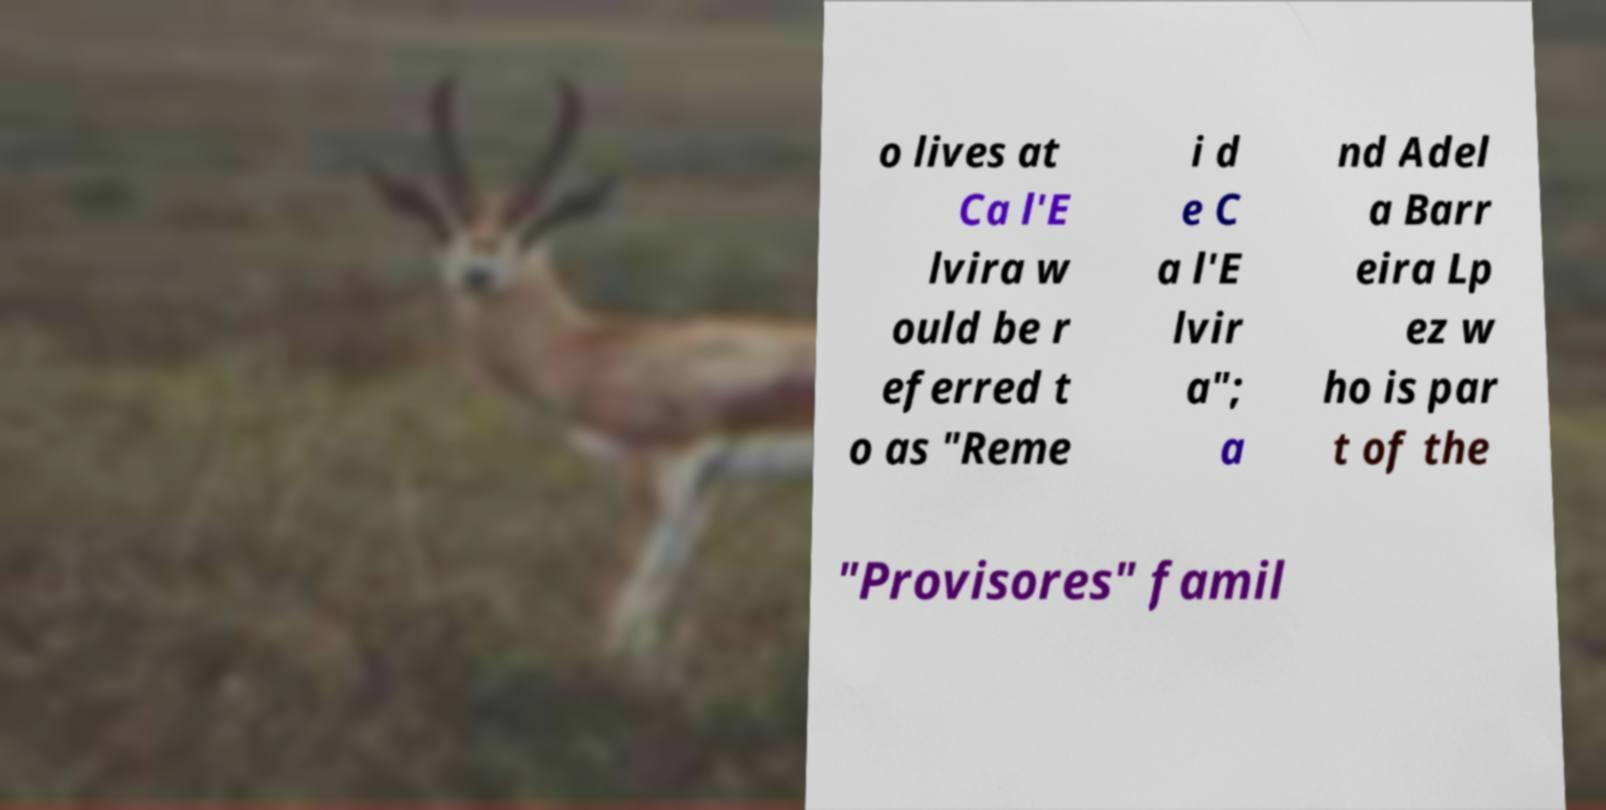There's text embedded in this image that I need extracted. Can you transcribe it verbatim? o lives at Ca l'E lvira w ould be r eferred t o as "Reme i d e C a l'E lvir a"; a nd Adel a Barr eira Lp ez w ho is par t of the "Provisores" famil 